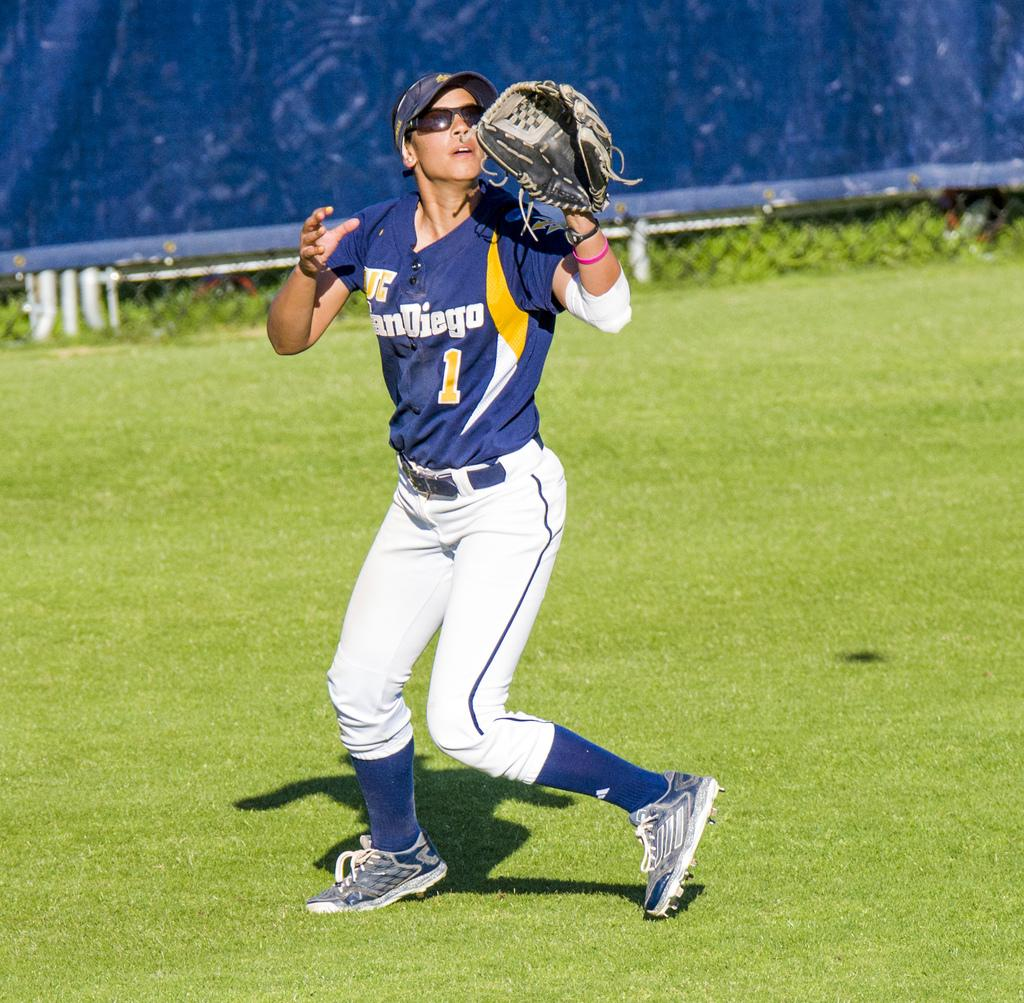Provide a one-sentence caption for the provided image. The number 1 player from San Diego attempts to catch a ball while looking into the sun. 